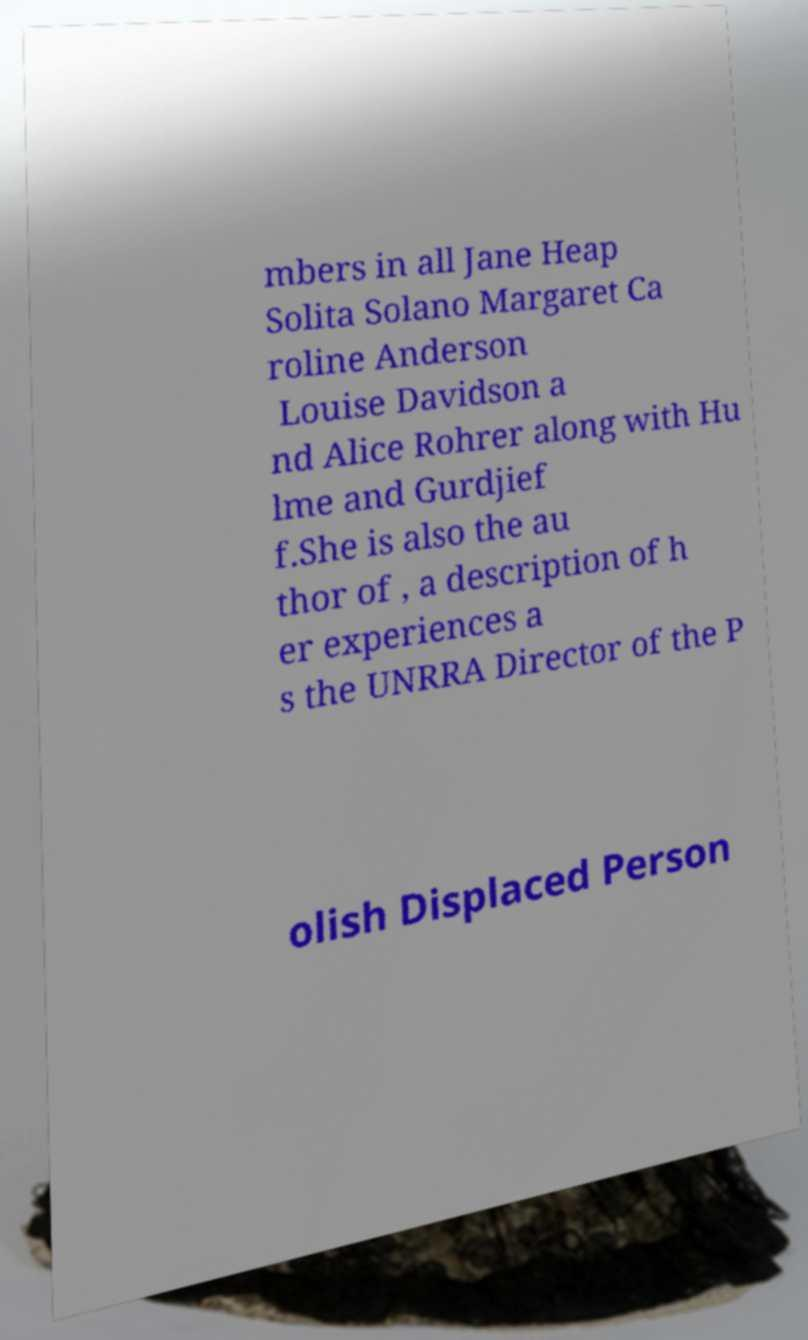Please read and relay the text visible in this image. What does it say? mbers in all Jane Heap Solita Solano Margaret Ca roline Anderson Louise Davidson a nd Alice Rohrer along with Hu lme and Gurdjief f.She is also the au thor of , a description of h er experiences a s the UNRRA Director of the P olish Displaced Person 